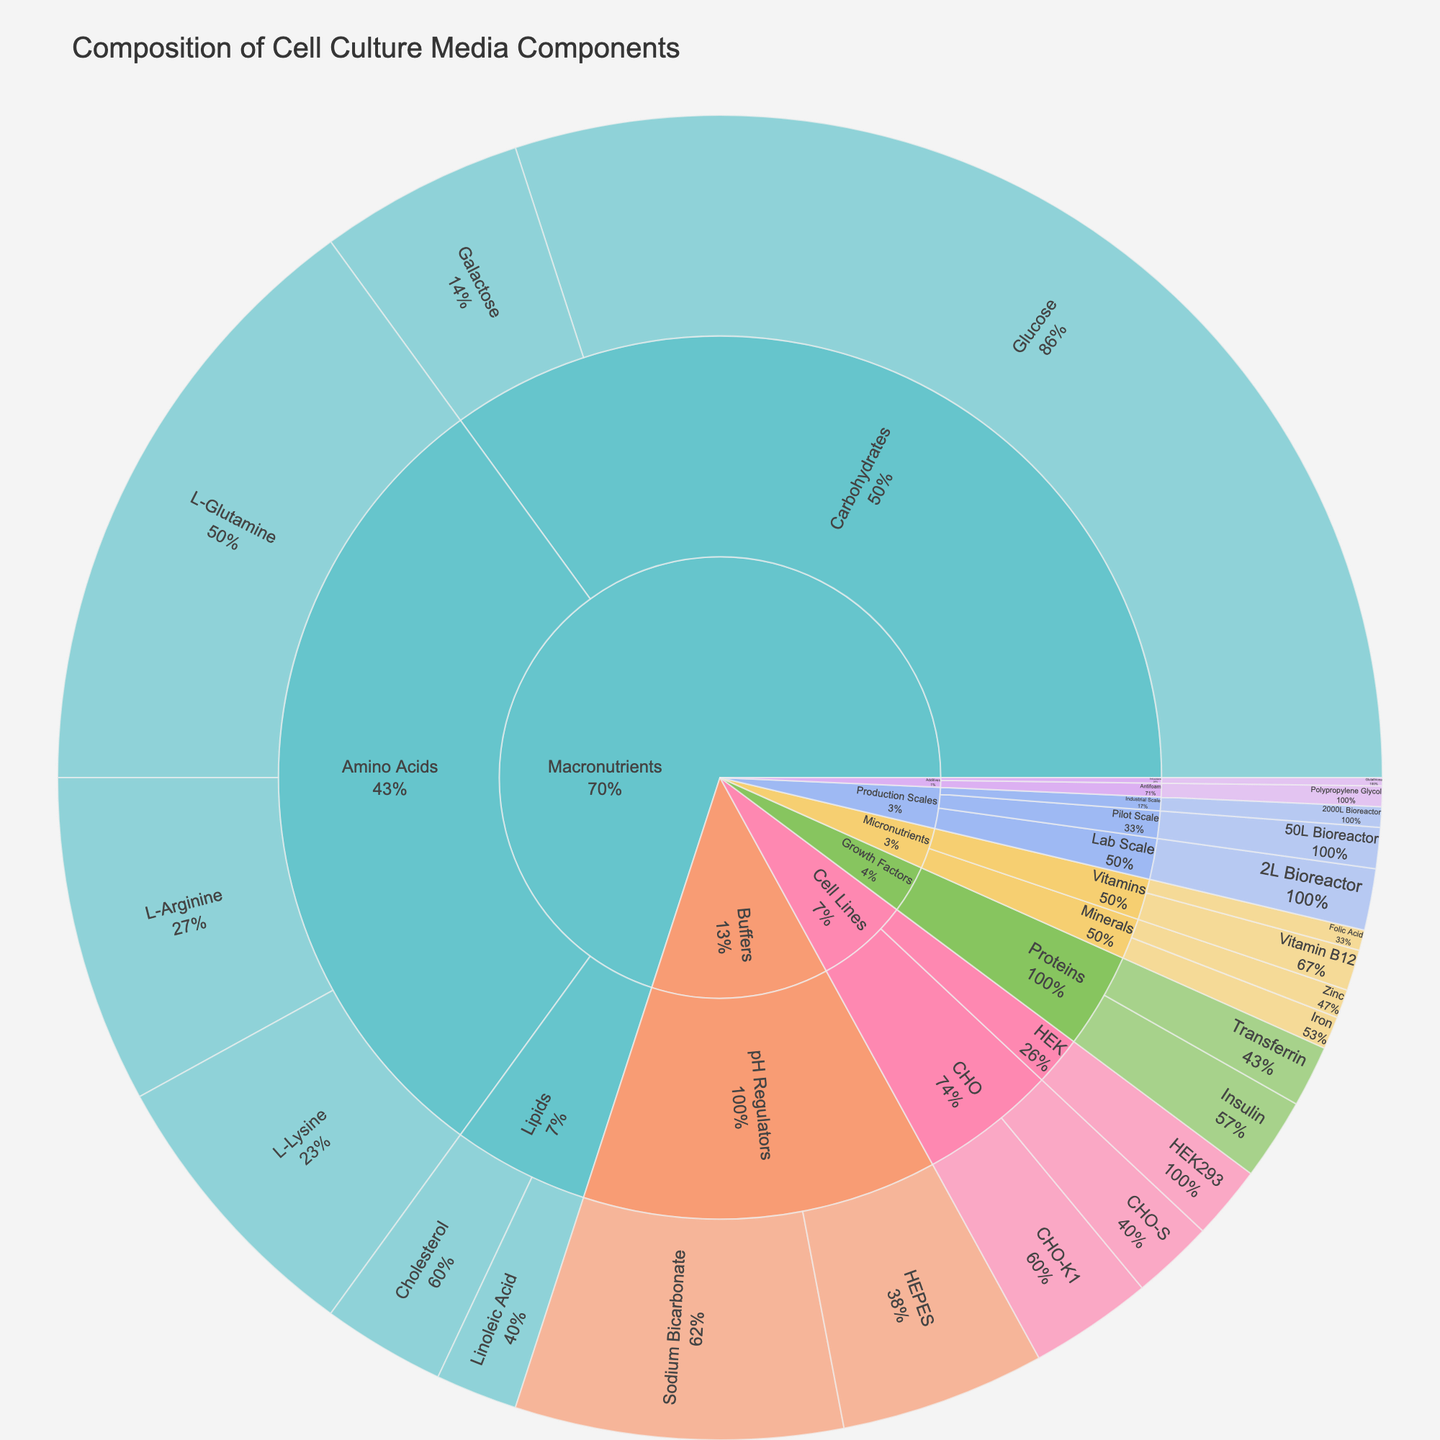What is the title of the figure? The title of a figure is typically displayed at the top of the plot and is meant to summarize the content or purpose of the visualization. In this case, the title should describe the overall content of the sunburst plot.
Answer: Composition of Cell Culture Media Components What is the percentage of Glucose in the cell culture media? The percentage of Glucose can be directly read from the corresponding segment in the sunburst plot within the Carbohydrates subcategory under Macronutrients.
Answer: 30% Which category contains the highest overall percentage of components? To determine which category has the highest percentage, sum the percentages of all components within each category and compare the sums. In this case, Macronutrients have the highest sum: 30% (Glucose) + 5% (Galactose) + 15% (L-Glutamine) + 8% (L-Arginine) + 7% (L-Lysine) + 3% (Cholesterol) + 2% (Linoleic Acid) = 70%.
Answer: Macronutrients How does the percentage of L-Glutamine compare to the percentage of L-Arginine? To compare the percentages, look at their individual values within the Amino Acids subcategory under Macronutrients. L-Glutamine has 15%, while L-Arginine has 8%.
Answer: L-Glutamine is higher If you sum up the percentages of all Buffers components, what do you get? Buffers include Sodium Bicarbonate (8%) and HEPES (5%). Adding these percentages gives 8% + 5% = 13%.
Answer: 13% Which subcategory within Micronutrients has a higher total percentage, Vitamins or Minerals? Sum the percentages of components within each subcategory and compare. Vitamins have 1% (Vitamin B12) + 0.5% (Folic Acid) = 1.5%. Minerals have 0.8% (Iron) + 0.7% (Zinc) = 1.5%. Both are equal.
Answer: They are equal What is the smallest component percentage in the Additives category? Within the Additives category, identify the smallest percentage component from the subcategories. Additives' smallest component is Glutathione (0.2%) under Antioxidants.
Answer: 0.2% List the cell lines represented in the plot and their corresponding percentages. By examining the plot for the Cell Lines category, we can find the individual cell lines and their percentages: CHO-K1 (3%), CHO-S (2%), and HEK293 (1.8%).
Answer: CHO-K1 (3%), CHO-S (2%), HEK293 (1.8%) What's the combined percentage of all the Growth Factors components? Add the percentages of the components within the Proteins subcategory under Growth Factors. Insulin has 2%, and Transferrin has 1.5%. So, the combined percentage is 2% + 1.5% = 3.5%.
Answer: 3.5% What percentage of the total media composition is contributed by the Production Scales components? Sum the percentages for all components within the Production Scales category: 2L Bioreactor (1.5%), 50L Bioreactor (1%), and 2000L Bioreactor (0.5%), which add up to 1.5% + 1% + 0.5% = 3%.
Answer: 3% 